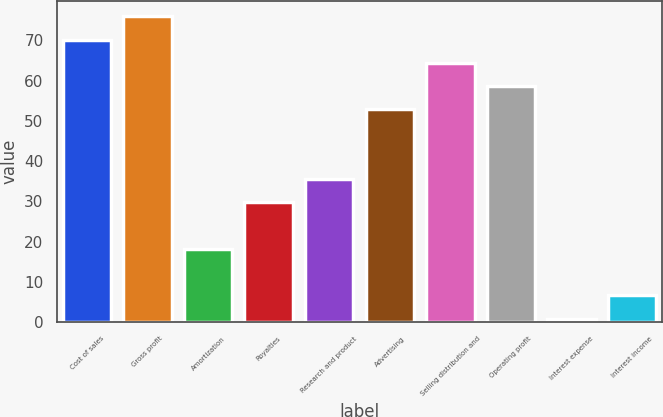<chart> <loc_0><loc_0><loc_500><loc_500><bar_chart><fcel>Cost of sales<fcel>Gross profit<fcel>Amortization<fcel>Royalties<fcel>Research and product<fcel>Advertising<fcel>Selling distribution and<fcel>Operating profit<fcel>Interest expense<fcel>Interest income<nl><fcel>70.14<fcel>75.91<fcel>18.21<fcel>29.75<fcel>35.52<fcel>52.83<fcel>64.37<fcel>58.6<fcel>0.9<fcel>6.67<nl></chart> 